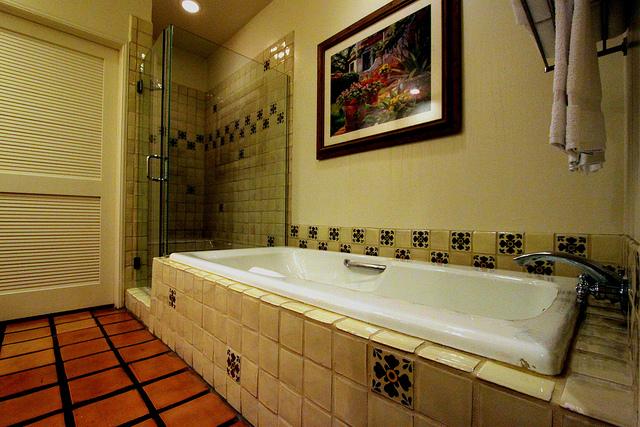What room is this?
Write a very short answer. Bathroom. Are the shower and the tub separated from each other?
Keep it brief. Yes. How many towels are seen?
Write a very short answer. 1. What is on the wall over the tub?
Keep it brief. Picture. 